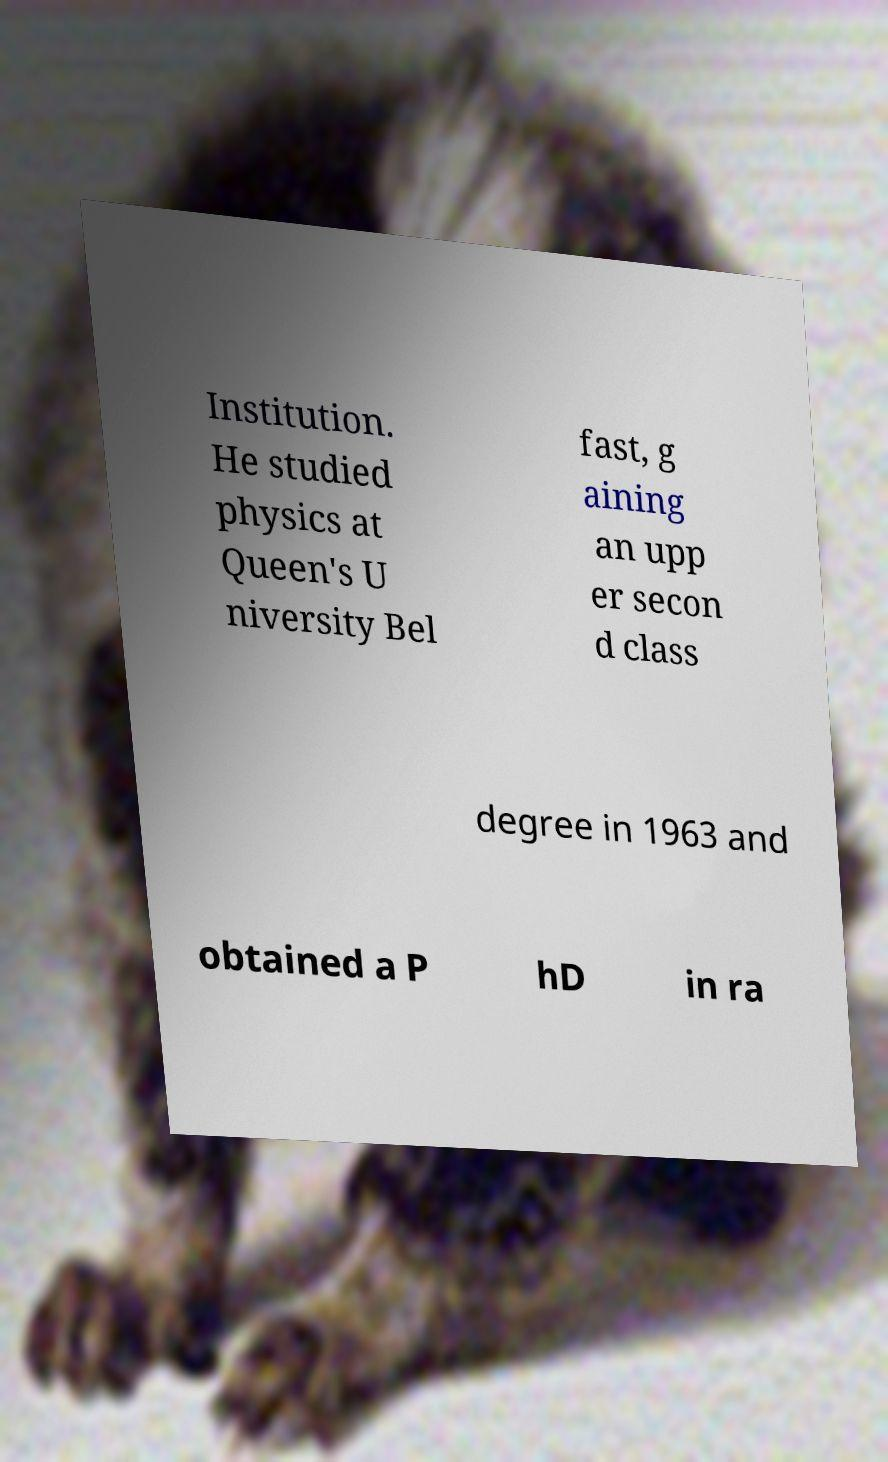Could you assist in decoding the text presented in this image and type it out clearly? Institution. He studied physics at Queen's U niversity Bel fast, g aining an upp er secon d class degree in 1963 and obtained a P hD in ra 